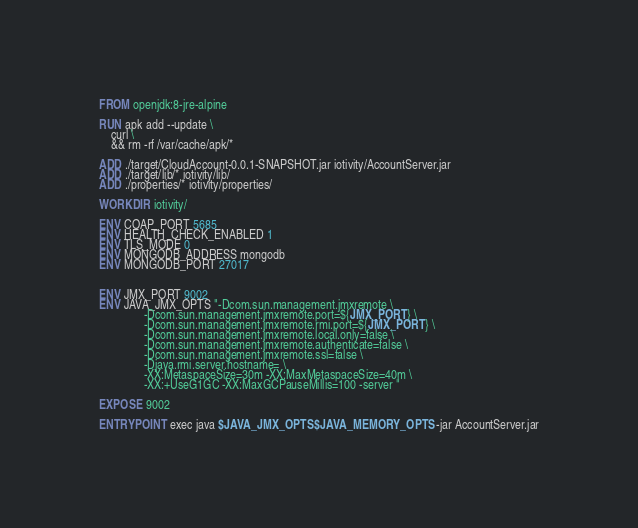Convert code to text. <code><loc_0><loc_0><loc_500><loc_500><_Dockerfile_>FROM openjdk:8-jre-alpine

RUN apk add --update \
    curl \
    && rm -rf /var/cache/apk/*

ADD ./target/CloudAccount-0.0.1-SNAPSHOT.jar iotivity/AccountServer.jar
ADD ./target/lib/* iotivity/lib/
ADD ./properties/* iotivity/properties/

WORKDIR iotivity/

ENV COAP_PORT 5685
ENV HEALTH_CHECK_ENABLED 1
ENV TLS_MODE 0
ENV MONGODB_ADDRESS mongodb
ENV MONGODB_PORT 27017


ENV JMX_PORT 9002
ENV JAVA_JMX_OPTS "-Dcom.sun.management.jmxremote \
               -Dcom.sun.management.jmxremote.port=${JMX_PORT} \
               -Dcom.sun.management.jmxremote.rmi.port=${JMX_PORT} \
               -Dcom.sun.management.jmxremote.local.only=false \
               -Dcom.sun.management.jmxremote.authenticate=false \
               -Dcom.sun.management.jmxremote.ssl=false \
               -Djava.rmi.server.hostname= \
               -XX:MetaspaceSize=30m -XX:MaxMetaspaceSize=40m \
               -XX:+UseG1GC -XX:MaxGCPauseMillis=100 -server "

EXPOSE 9002

ENTRYPOINT exec java $JAVA_JMX_OPTS $JAVA_MEMORY_OPTS -jar AccountServer.jar</code> 